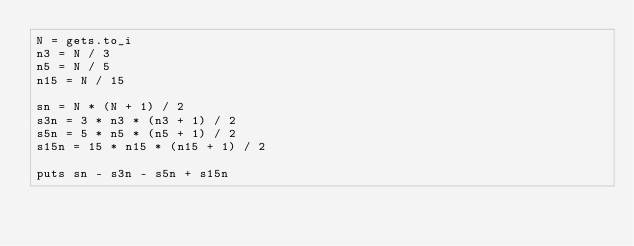<code> <loc_0><loc_0><loc_500><loc_500><_Ruby_>N = gets.to_i
n3 = N / 3
n5 = N / 5
n15 = N / 15

sn = N * (N + 1) / 2
s3n = 3 * n3 * (n3 + 1) / 2
s5n = 5 * n5 * (n5 + 1) / 2
s15n = 15 * n15 * (n15 + 1) / 2

puts sn - s3n - s5n + s15n
</code> 